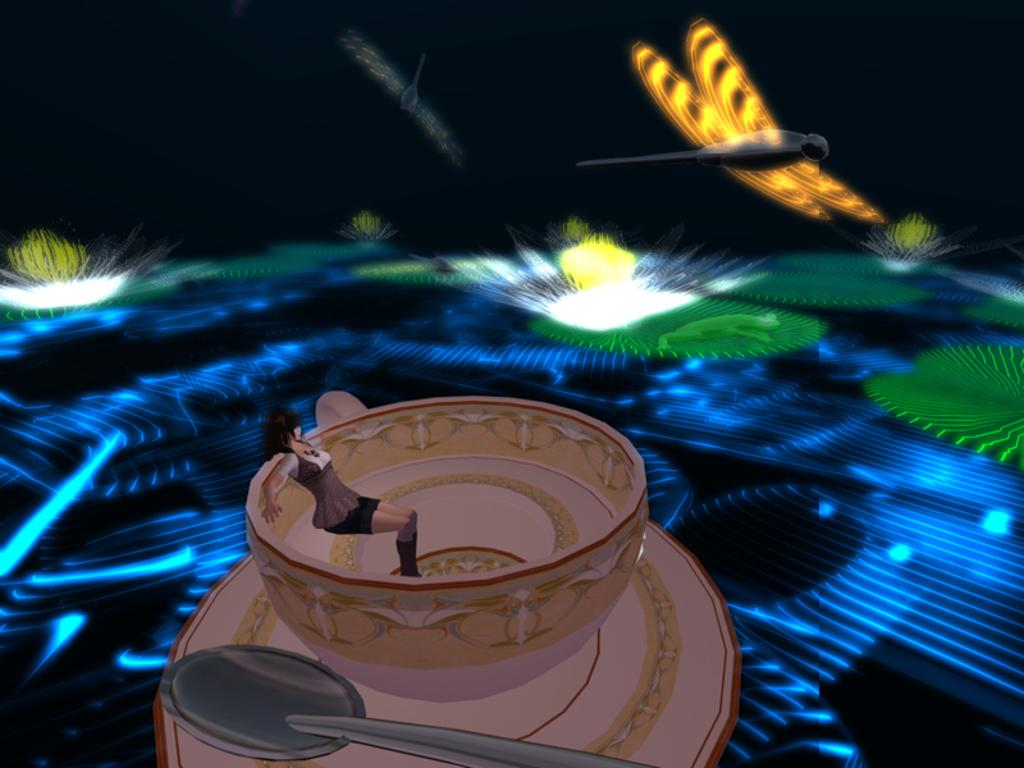What type of image is being described? The image is animated. Can you describe the characters or objects in the image? There is a girl, a cup, a spoon, and a flower in the image. What type of act is the girl performing with the hammer in the image? There is no hammer present in the image; it only features a girl, a cup, a spoon, and a flower. 